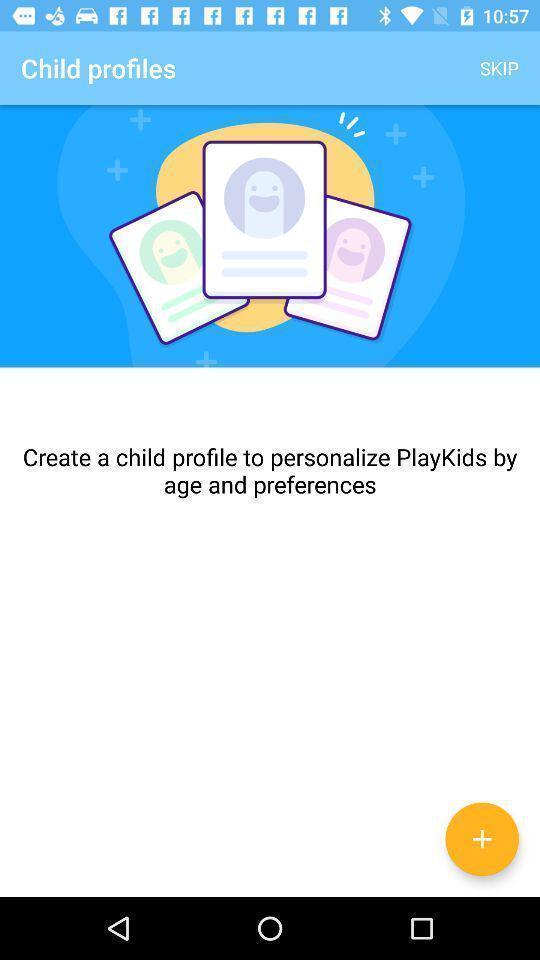What can you discern from this picture? Screen displaying the child profile page. 